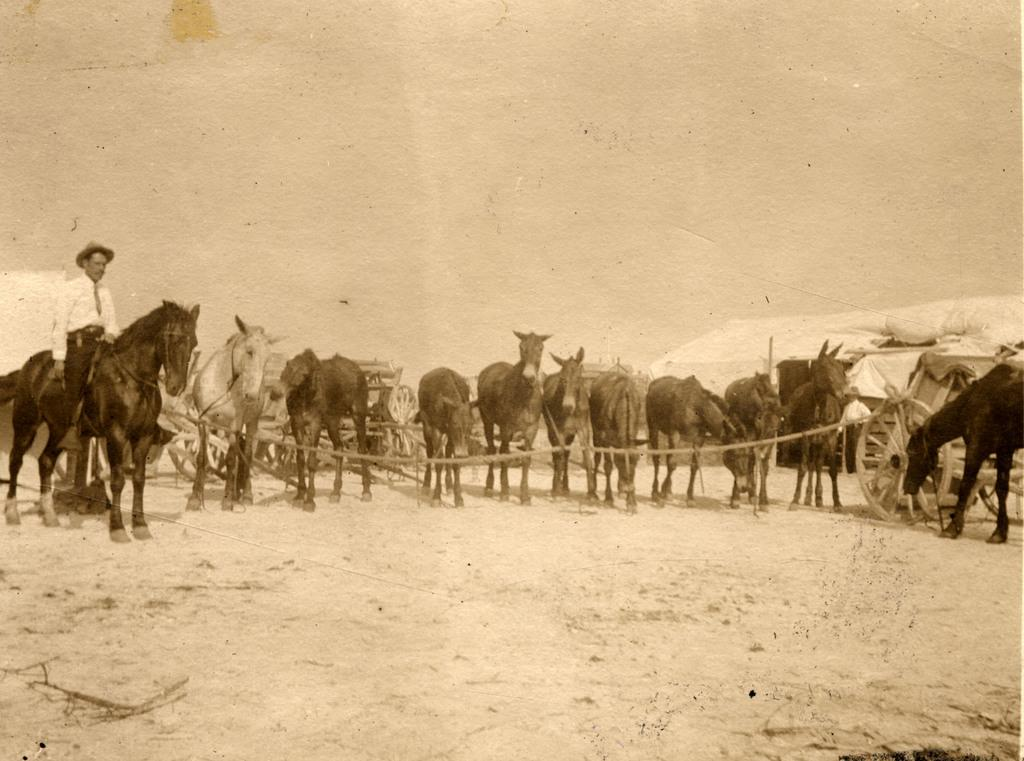What animals are present in the image? There is a group of horses in the image. What are the horses doing in the image? The horses are standing in the image. What objects can be seen on the ground in the image? There are carts on the ground in the image. Can you describe the man in the image? The man is sitting on a horse in the image. What is the color scheme of the image? The image is black and white. How many pies are being held by the ghost in the image? There is no ghost or pies present in the image. What type of roof is visible in the image? There is no roof visible in the image; it is an open area with horses and carts. 